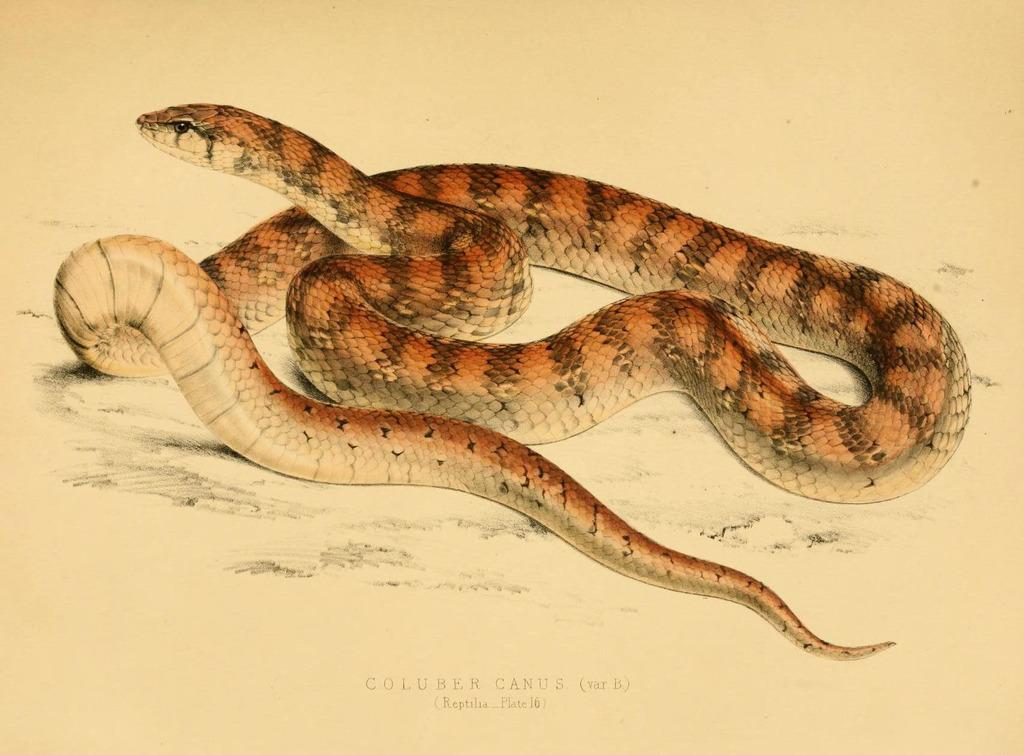What animal is depicted in the image? There is a depiction of a snake in the image. What colors can be seen on the snake? The snake's color is brown and cream. Is there any text present in the image? Yes, there is text written on the bottom side of the image. What type of joke is being told by the snake in the image? There is no joke being told by the snake in the image; it is a static depiction of a snake. 